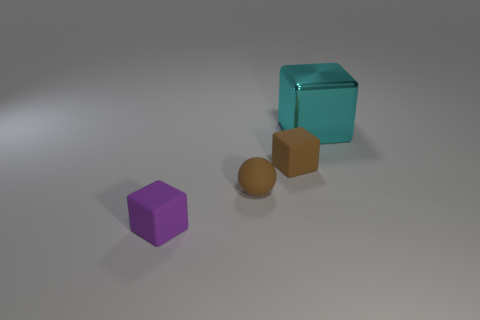Subtract all small brown matte blocks. How many blocks are left? 2 Subtract all brown blocks. How many blocks are left? 2 Subtract all spheres. How many objects are left? 3 Subtract 1 cubes. How many cubes are left? 2 Add 4 small brown spheres. How many objects exist? 8 Subtract 0 red cubes. How many objects are left? 4 Subtract all yellow spheres. Subtract all blue cylinders. How many spheres are left? 1 Subtract all cyan shiny cubes. Subtract all tiny balls. How many objects are left? 2 Add 2 large metal cubes. How many large metal cubes are left? 3 Add 3 balls. How many balls exist? 4 